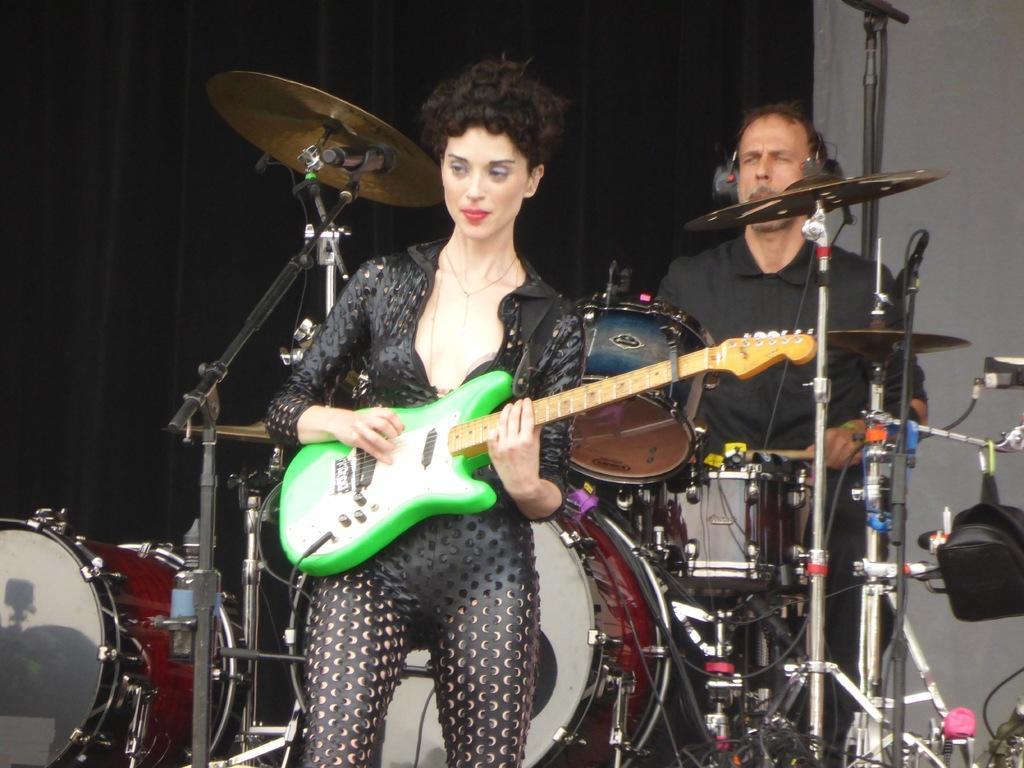Can you describe this image briefly? In this image we can see a woman is standing and playing green color guitar. She is wearing black color costume. Behind her one man is playing drums and black color curtain is present. 